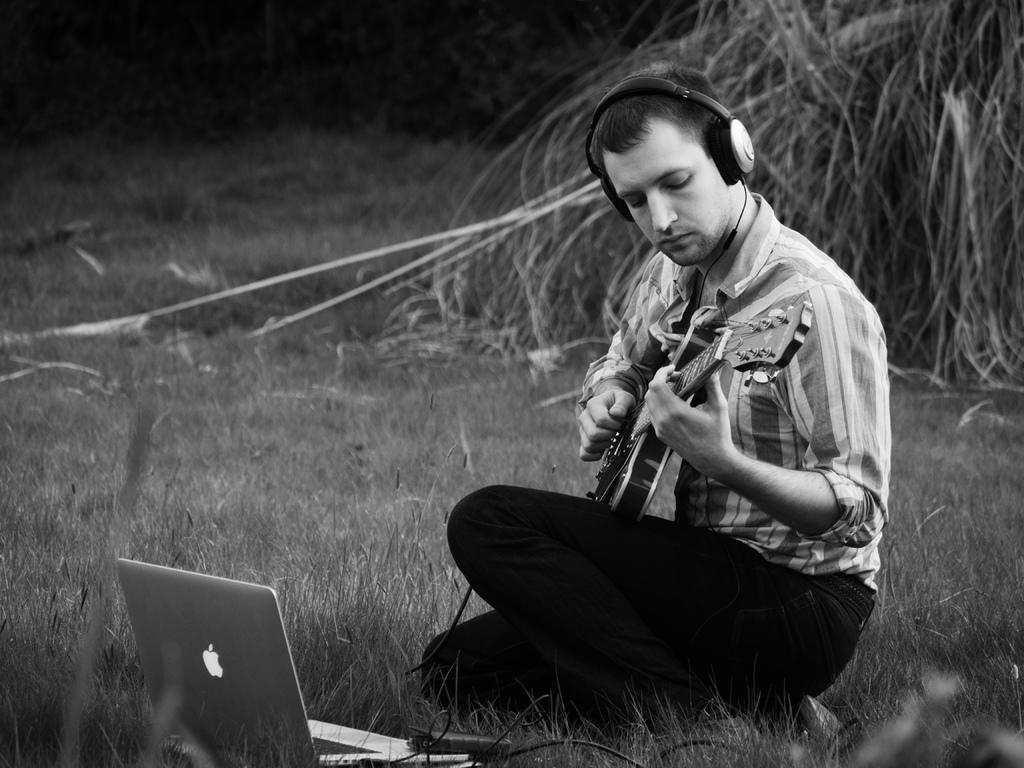What is the man in the image doing? The man is sitting on grass and playing a guitar. Where is the man located in the image? The man is sitting on grass in the image. What other object can be seen in the image besides the man and the guitar? There is a laptop in the image. Is there a fight happening on a stage in the image? There is no fight or stage present in the image. What type of weather is depicted in the image? The provided facts do not mention any weather conditions, so it cannot be determined from the image. 